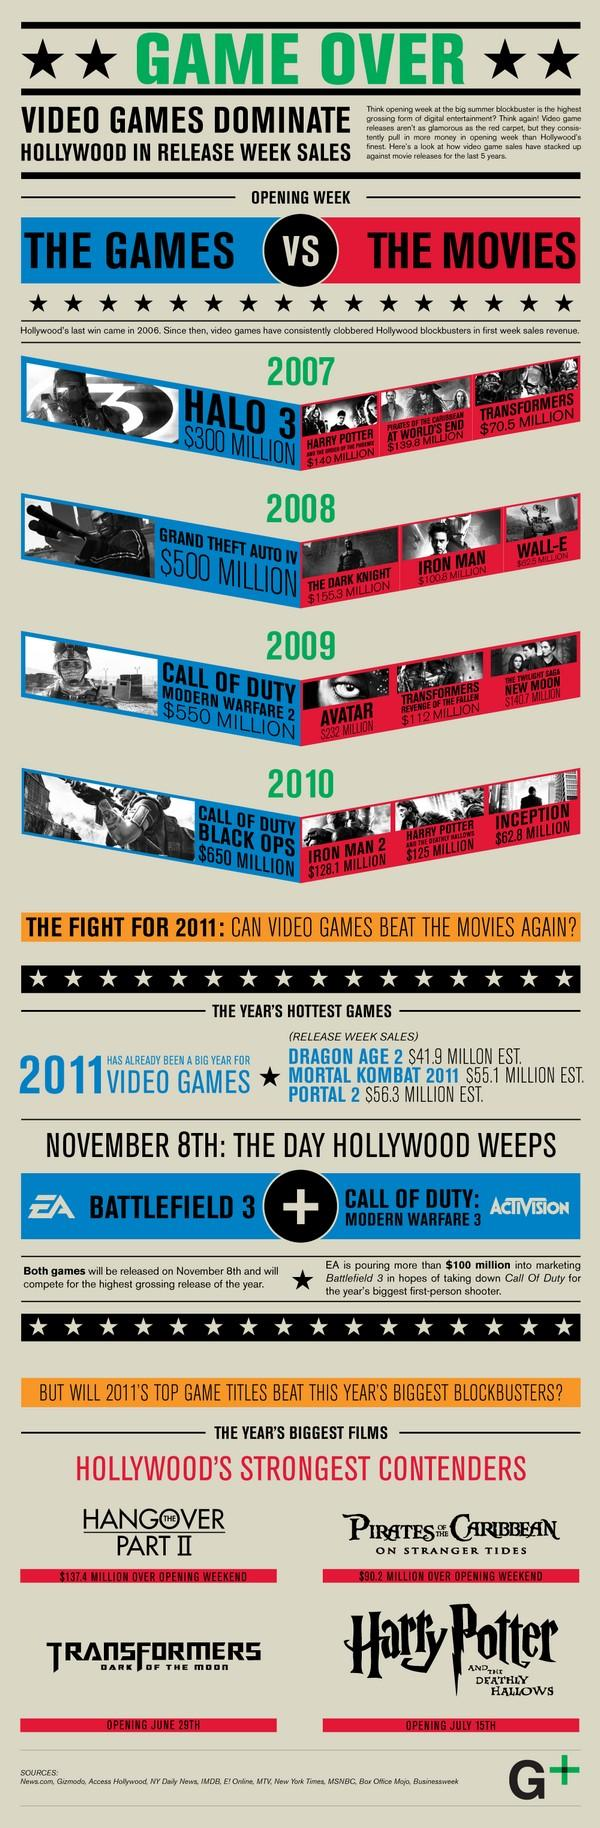Mention a couple of crucial points in this snapshot. The comparison of Iron Man's first week sales to the release of Grand Theft Auto IV in 2008 is being made against the game that was released during the first week of its release. In 2009 and 2010, multiple versions of the Call of Duty game were released. The sales revenue of Harry Potter in the first week of its release in 2007 was reported to be $140 million. After reaching the game over screen, there are two stars remaining. The first week revenue of Halo 3 was $229.5 million, which was significantly higher than the revenue generated by Transformers in its first week. 